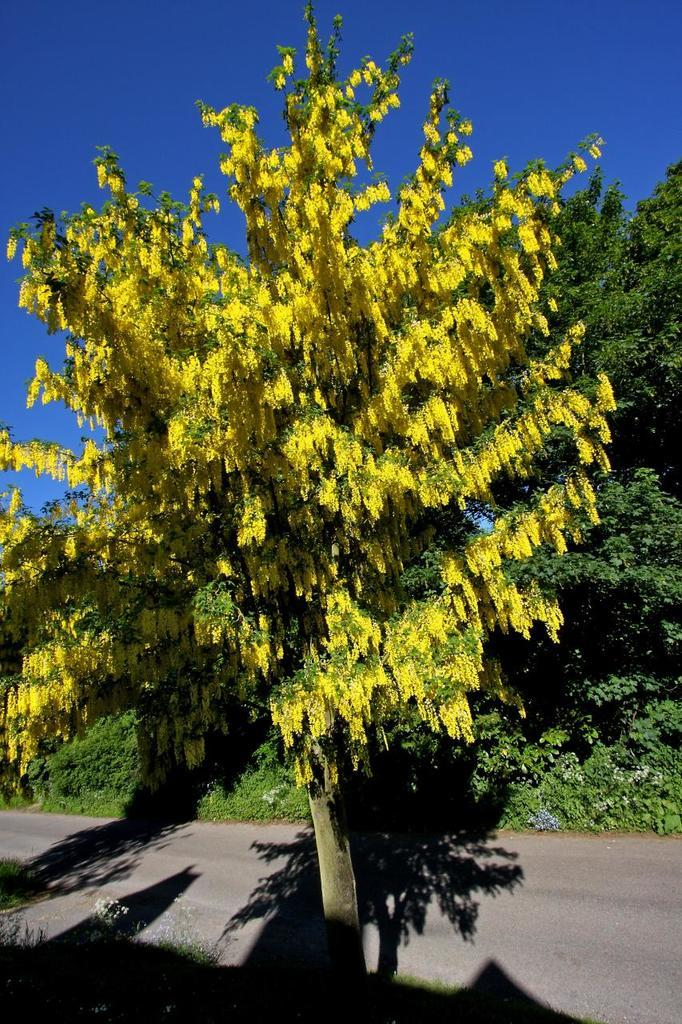What is located in the foreground of the image? There is a tree in the foreground of the image. What is located behind the tree in the image? There is a road behind the tree. What can be seen in the background of the image? There are trees and the sky visible in the background of the image. Where is the hospital located in the image? There is no hospital present in the image. What type of love can be seen expressed between the trees in the image? There is no expression of love between the trees in the image; they are simply trees. 